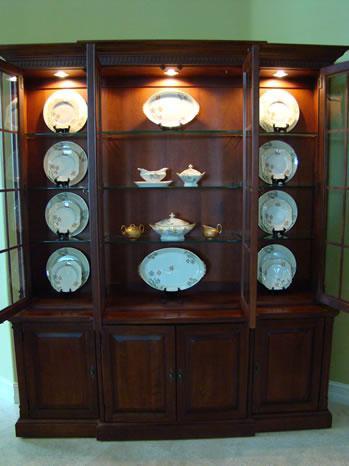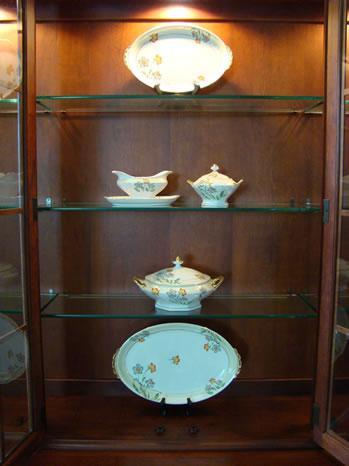The first image is the image on the left, the second image is the image on the right. Analyze the images presented: Is the assertion "At least two lights are seen at the top of the interior of a china cabinet." valid? Answer yes or no. Yes. 